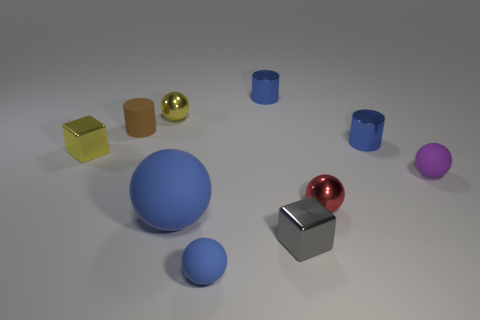Subtract all small rubber cylinders. How many cylinders are left? 2 Subtract all brown cylinders. How many cylinders are left? 2 Subtract all purple cylinders. How many blue balls are left? 2 Subtract all cylinders. How many objects are left? 7 Subtract 3 balls. How many balls are left? 2 Subtract all red blocks. Subtract all blue balls. How many blocks are left? 2 Subtract all brown matte things. Subtract all yellow metal spheres. How many objects are left? 8 Add 1 tiny gray metallic objects. How many tiny gray metallic objects are left? 2 Add 6 tiny yellow shiny things. How many tiny yellow shiny things exist? 8 Subtract 1 purple balls. How many objects are left? 9 